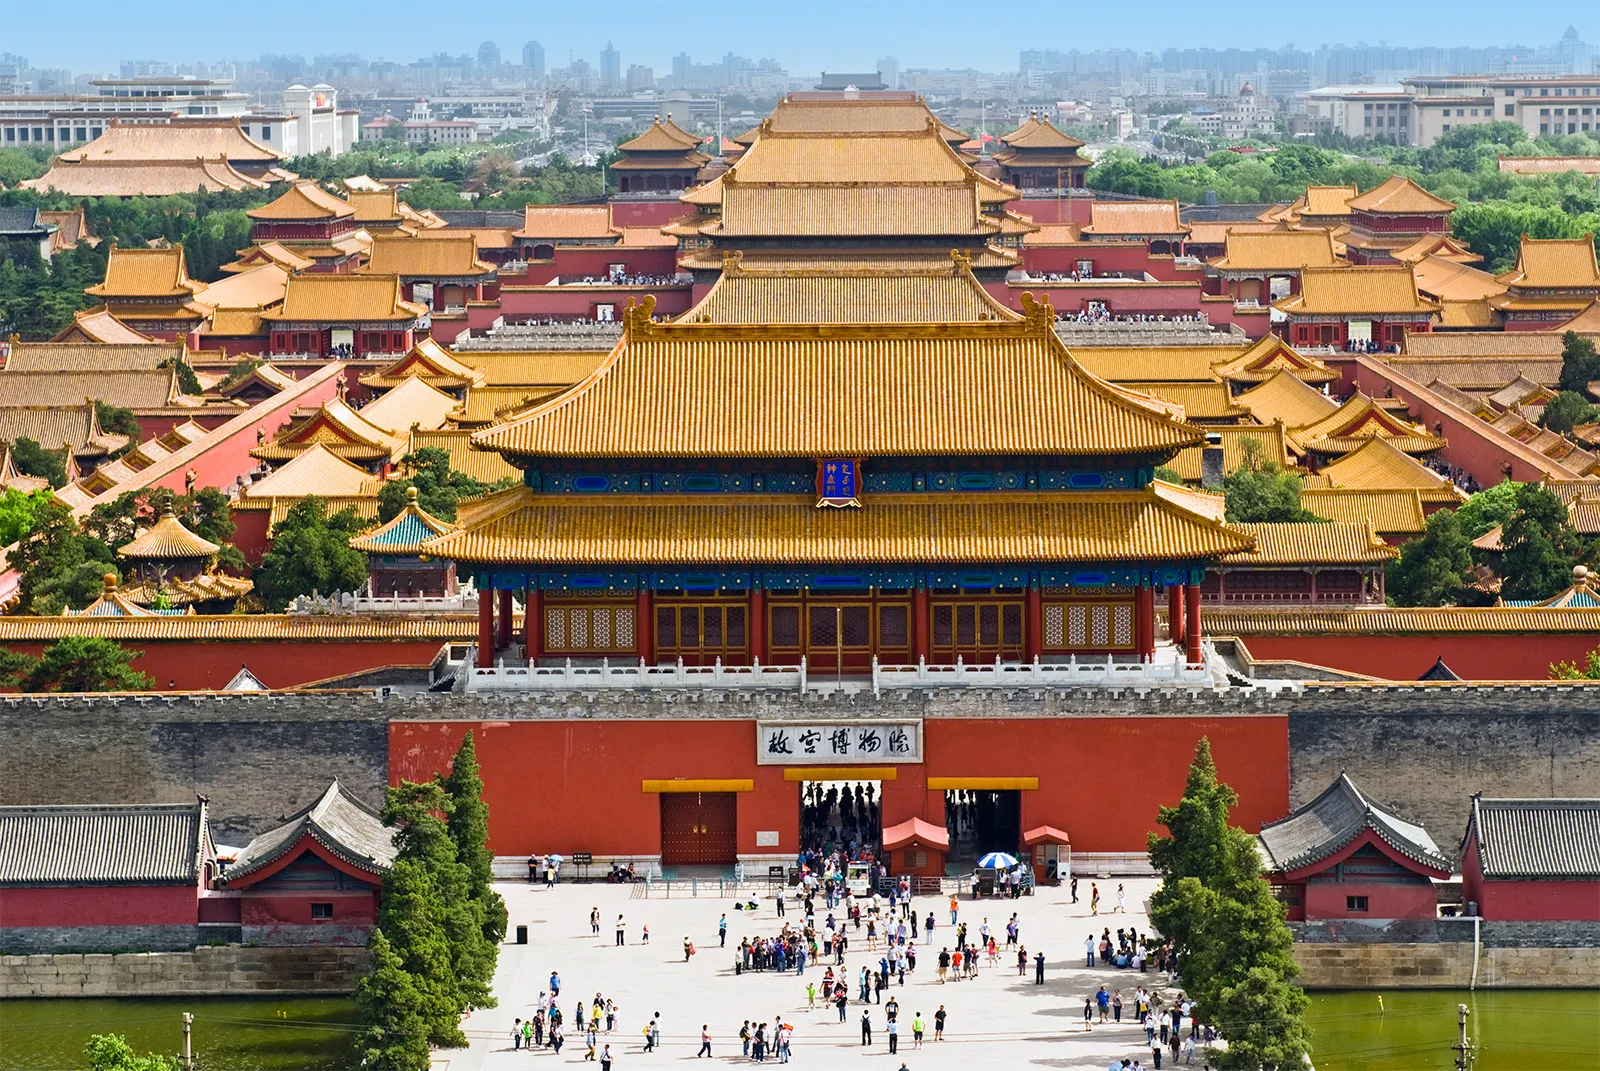Explain the visual content of the image in great detail. The image offers a panoramic aerial view of the Forbidden City, Beijing's iconic palace complex from the Ming and Qing dynasties. Dominating the foreground is the Meridian Gate, the main gate to the former imperial palace, leading to the grand Outer Court. Behind it rises the Hall of Supreme Harmony, nestled between lesser, though similarly impressive, structures all roofed in golden tiles, symbolizing imperial power. The complex's red walls and golden roofs contrast with the greenish-blue hue of the surrounding moat, reflecting some of the buildings. Scattered across the expansive courtyards are numerous visitors, underscoring the site's popularity as a cultural and historical monument attracting tourists worldwide. The precise, planned layout of the buildings and the vast open spaces evoke the grandeur and authority of historical Chinese dynasties. 